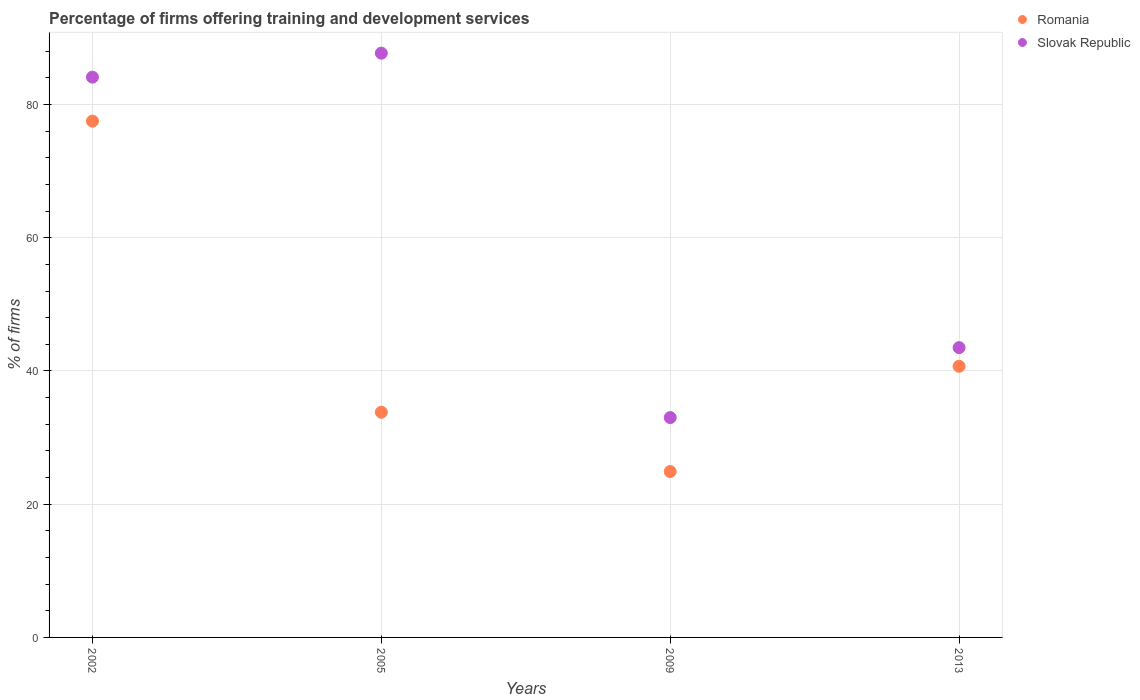Is the number of dotlines equal to the number of legend labels?
Ensure brevity in your answer.  Yes. What is the percentage of firms offering training and development in Romania in 2009?
Offer a very short reply. 24.9. Across all years, what is the maximum percentage of firms offering training and development in Slovak Republic?
Provide a succinct answer. 87.7. Across all years, what is the minimum percentage of firms offering training and development in Slovak Republic?
Provide a succinct answer. 33. What is the total percentage of firms offering training and development in Romania in the graph?
Your answer should be very brief. 176.9. What is the difference between the percentage of firms offering training and development in Slovak Republic in 2002 and that in 2009?
Give a very brief answer. 51.1. What is the difference between the percentage of firms offering training and development in Romania in 2002 and the percentage of firms offering training and development in Slovak Republic in 2013?
Your response must be concise. 34. What is the average percentage of firms offering training and development in Slovak Republic per year?
Offer a very short reply. 62.08. In the year 2002, what is the difference between the percentage of firms offering training and development in Romania and percentage of firms offering training and development in Slovak Republic?
Make the answer very short. -6.6. What is the ratio of the percentage of firms offering training and development in Romania in 2002 to that in 2009?
Keep it short and to the point. 3.11. What is the difference between the highest and the second highest percentage of firms offering training and development in Romania?
Offer a very short reply. 36.8. What is the difference between the highest and the lowest percentage of firms offering training and development in Slovak Republic?
Your response must be concise. 54.7. In how many years, is the percentage of firms offering training and development in Slovak Republic greater than the average percentage of firms offering training and development in Slovak Republic taken over all years?
Give a very brief answer. 2. Does the percentage of firms offering training and development in Slovak Republic monotonically increase over the years?
Make the answer very short. No. Is the percentage of firms offering training and development in Slovak Republic strictly greater than the percentage of firms offering training and development in Romania over the years?
Ensure brevity in your answer.  Yes. What is the difference between two consecutive major ticks on the Y-axis?
Keep it short and to the point. 20. Are the values on the major ticks of Y-axis written in scientific E-notation?
Your answer should be compact. No. Where does the legend appear in the graph?
Keep it short and to the point. Top right. How many legend labels are there?
Offer a terse response. 2. How are the legend labels stacked?
Your response must be concise. Vertical. What is the title of the graph?
Offer a terse response. Percentage of firms offering training and development services. What is the label or title of the Y-axis?
Offer a terse response. % of firms. What is the % of firms of Romania in 2002?
Ensure brevity in your answer.  77.5. What is the % of firms in Slovak Republic in 2002?
Your response must be concise. 84.1. What is the % of firms of Romania in 2005?
Provide a short and direct response. 33.8. What is the % of firms of Slovak Republic in 2005?
Your response must be concise. 87.7. What is the % of firms in Romania in 2009?
Provide a short and direct response. 24.9. What is the % of firms of Slovak Republic in 2009?
Your answer should be very brief. 33. What is the % of firms of Romania in 2013?
Your response must be concise. 40.7. What is the % of firms in Slovak Republic in 2013?
Your answer should be compact. 43.5. Across all years, what is the maximum % of firms in Romania?
Your response must be concise. 77.5. Across all years, what is the maximum % of firms in Slovak Republic?
Provide a succinct answer. 87.7. Across all years, what is the minimum % of firms in Romania?
Keep it short and to the point. 24.9. Across all years, what is the minimum % of firms of Slovak Republic?
Your answer should be very brief. 33. What is the total % of firms of Romania in the graph?
Your answer should be very brief. 176.9. What is the total % of firms in Slovak Republic in the graph?
Your answer should be compact. 248.3. What is the difference between the % of firms in Romania in 2002 and that in 2005?
Offer a terse response. 43.7. What is the difference between the % of firms of Slovak Republic in 2002 and that in 2005?
Your response must be concise. -3.6. What is the difference between the % of firms of Romania in 2002 and that in 2009?
Offer a terse response. 52.6. What is the difference between the % of firms of Slovak Republic in 2002 and that in 2009?
Ensure brevity in your answer.  51.1. What is the difference between the % of firms of Romania in 2002 and that in 2013?
Your answer should be compact. 36.8. What is the difference between the % of firms in Slovak Republic in 2002 and that in 2013?
Offer a terse response. 40.6. What is the difference between the % of firms of Romania in 2005 and that in 2009?
Give a very brief answer. 8.9. What is the difference between the % of firms of Slovak Republic in 2005 and that in 2009?
Keep it short and to the point. 54.7. What is the difference between the % of firms in Romania in 2005 and that in 2013?
Provide a short and direct response. -6.9. What is the difference between the % of firms in Slovak Republic in 2005 and that in 2013?
Provide a short and direct response. 44.2. What is the difference between the % of firms in Romania in 2009 and that in 2013?
Make the answer very short. -15.8. What is the difference between the % of firms of Slovak Republic in 2009 and that in 2013?
Provide a short and direct response. -10.5. What is the difference between the % of firms in Romania in 2002 and the % of firms in Slovak Republic in 2005?
Make the answer very short. -10.2. What is the difference between the % of firms in Romania in 2002 and the % of firms in Slovak Republic in 2009?
Make the answer very short. 44.5. What is the difference between the % of firms of Romania in 2005 and the % of firms of Slovak Republic in 2009?
Give a very brief answer. 0.8. What is the difference between the % of firms of Romania in 2005 and the % of firms of Slovak Republic in 2013?
Your response must be concise. -9.7. What is the difference between the % of firms in Romania in 2009 and the % of firms in Slovak Republic in 2013?
Give a very brief answer. -18.6. What is the average % of firms in Romania per year?
Your answer should be compact. 44.23. What is the average % of firms of Slovak Republic per year?
Provide a succinct answer. 62.08. In the year 2002, what is the difference between the % of firms of Romania and % of firms of Slovak Republic?
Make the answer very short. -6.6. In the year 2005, what is the difference between the % of firms in Romania and % of firms in Slovak Republic?
Ensure brevity in your answer.  -53.9. In the year 2009, what is the difference between the % of firms in Romania and % of firms in Slovak Republic?
Offer a very short reply. -8.1. What is the ratio of the % of firms in Romania in 2002 to that in 2005?
Your answer should be very brief. 2.29. What is the ratio of the % of firms of Slovak Republic in 2002 to that in 2005?
Offer a very short reply. 0.96. What is the ratio of the % of firms in Romania in 2002 to that in 2009?
Provide a short and direct response. 3.11. What is the ratio of the % of firms in Slovak Republic in 2002 to that in 2009?
Provide a short and direct response. 2.55. What is the ratio of the % of firms of Romania in 2002 to that in 2013?
Give a very brief answer. 1.9. What is the ratio of the % of firms in Slovak Republic in 2002 to that in 2013?
Your answer should be very brief. 1.93. What is the ratio of the % of firms in Romania in 2005 to that in 2009?
Give a very brief answer. 1.36. What is the ratio of the % of firms in Slovak Republic in 2005 to that in 2009?
Offer a terse response. 2.66. What is the ratio of the % of firms of Romania in 2005 to that in 2013?
Provide a succinct answer. 0.83. What is the ratio of the % of firms of Slovak Republic in 2005 to that in 2013?
Give a very brief answer. 2.02. What is the ratio of the % of firms of Romania in 2009 to that in 2013?
Make the answer very short. 0.61. What is the ratio of the % of firms of Slovak Republic in 2009 to that in 2013?
Provide a short and direct response. 0.76. What is the difference between the highest and the second highest % of firms of Romania?
Make the answer very short. 36.8. What is the difference between the highest and the second highest % of firms in Slovak Republic?
Your answer should be compact. 3.6. What is the difference between the highest and the lowest % of firms in Romania?
Your response must be concise. 52.6. What is the difference between the highest and the lowest % of firms of Slovak Republic?
Your answer should be very brief. 54.7. 